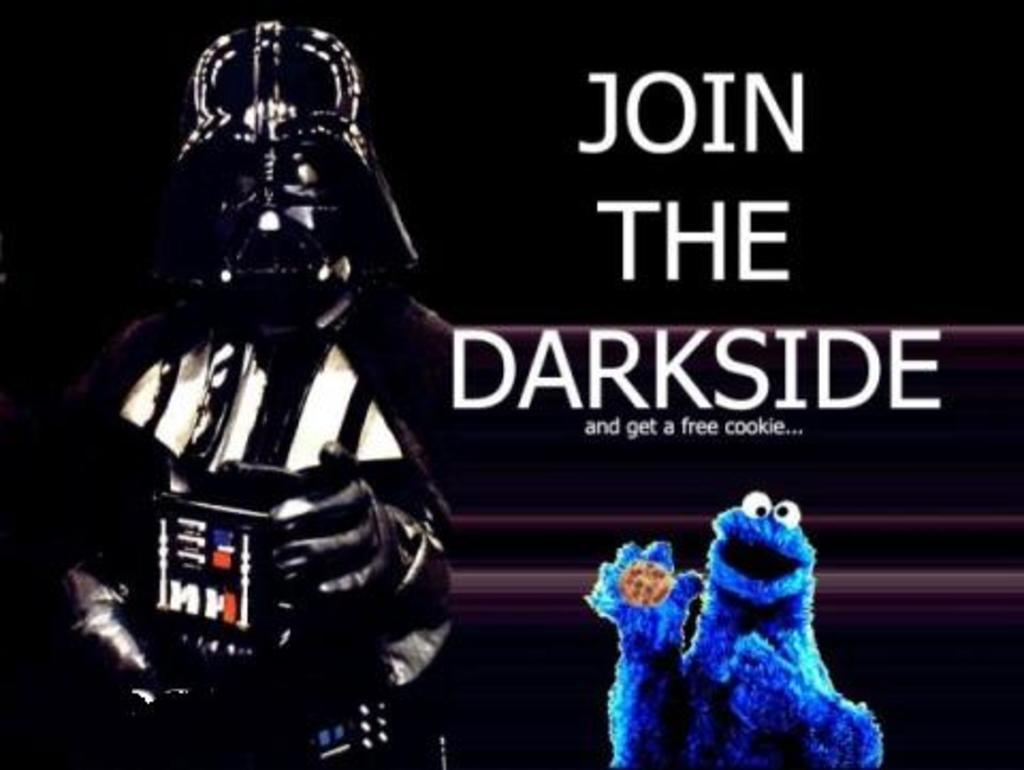What is the person in the image holding? The person is holding a device in the image. Can you describe the person's attire in the image? The person is wearing a costume in the image. What else can be seen in the image besides the person and the device? There is text visible in the image, as well as a doll holding a cookie. What type of songs can be heard coming from the device in the image? There is no indication in the image that the device is playing any songs, so it's not possible to determine what, if any, songs might be heard. 